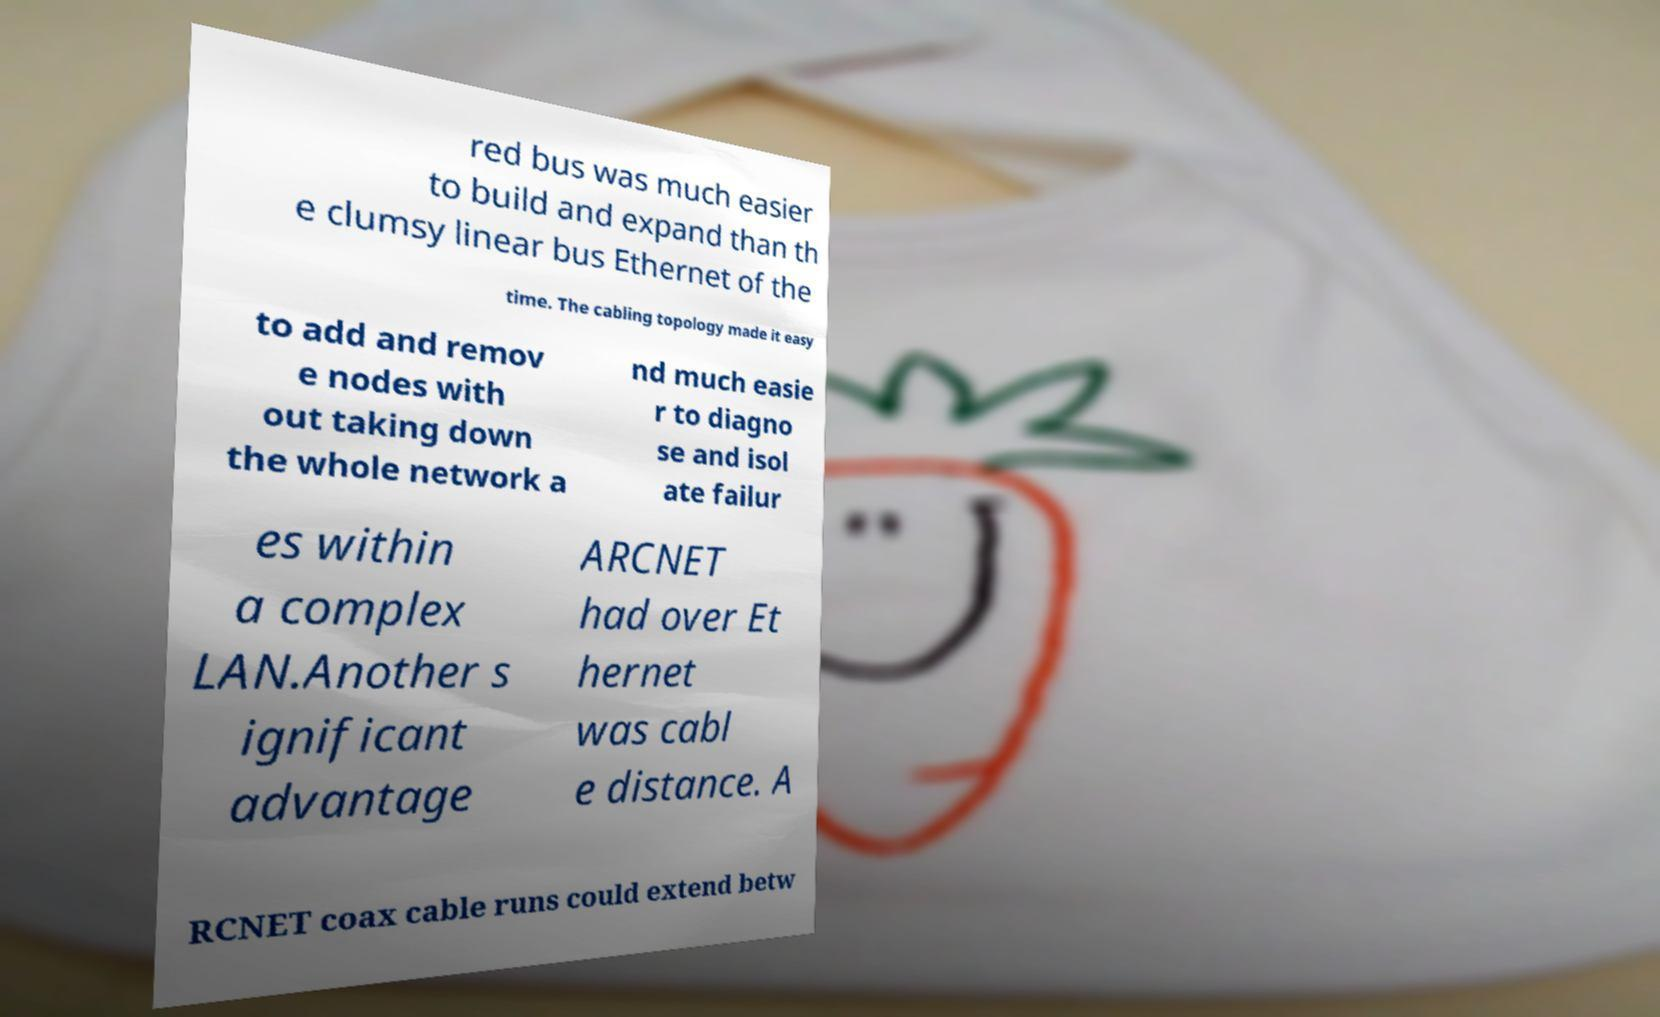What messages or text are displayed in this image? I need them in a readable, typed format. red bus was much easier to build and expand than th e clumsy linear bus Ethernet of the time. The cabling topology made it easy to add and remov e nodes with out taking down the whole network a nd much easie r to diagno se and isol ate failur es within a complex LAN.Another s ignificant advantage ARCNET had over Et hernet was cabl e distance. A RCNET coax cable runs could extend betw 